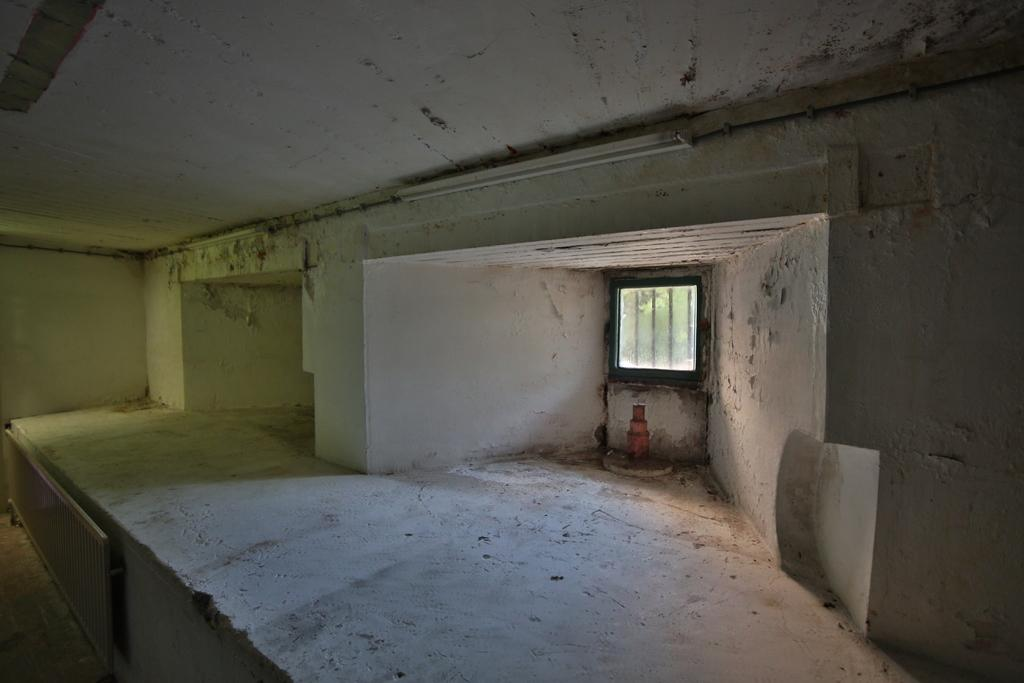What is located at the top of the image? There is a ceiling at the top of the image. What is located at the bottom of the image? There is a floor at the bottom of the image. What is present on the sides of the image? There is a wall in the image. What can be seen in the wall? There is a glass window in the wall. What type of advertisement can be seen on the wall in the image? There is no advertisement present on the wall in the image. What type of fruit is hanging from the ceiling in the image? There is no fruit hanging from the ceiling in the image. 